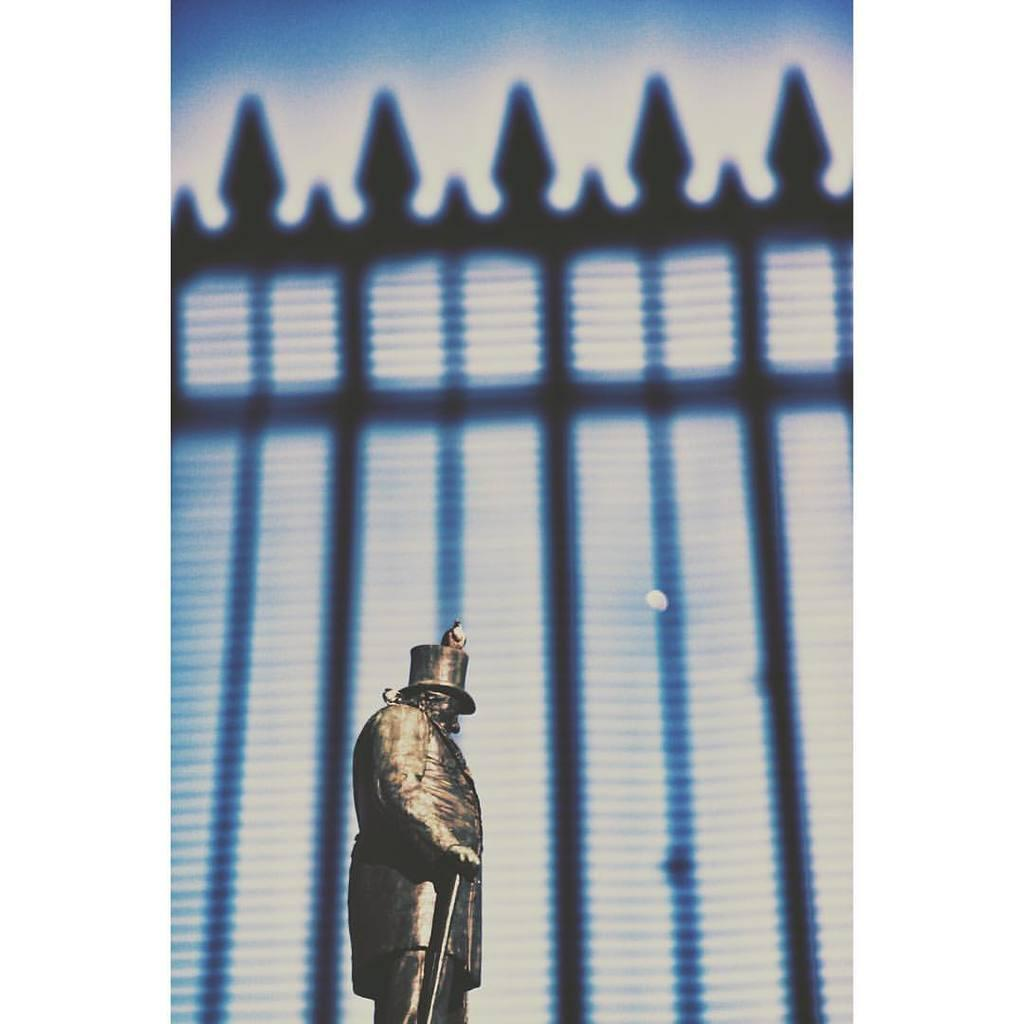What is the main subject in the image? There is a statue in the image. Can you describe the statue? Unfortunately, the provided facts do not give any details about the statue's appearance or characteristics. What can be seen in the background of the image? There is a wall-like structure in the background of the image. What type of bone is visible in the image? There is no bone present in the image; it features a statue and a wall-like structure in the background. 